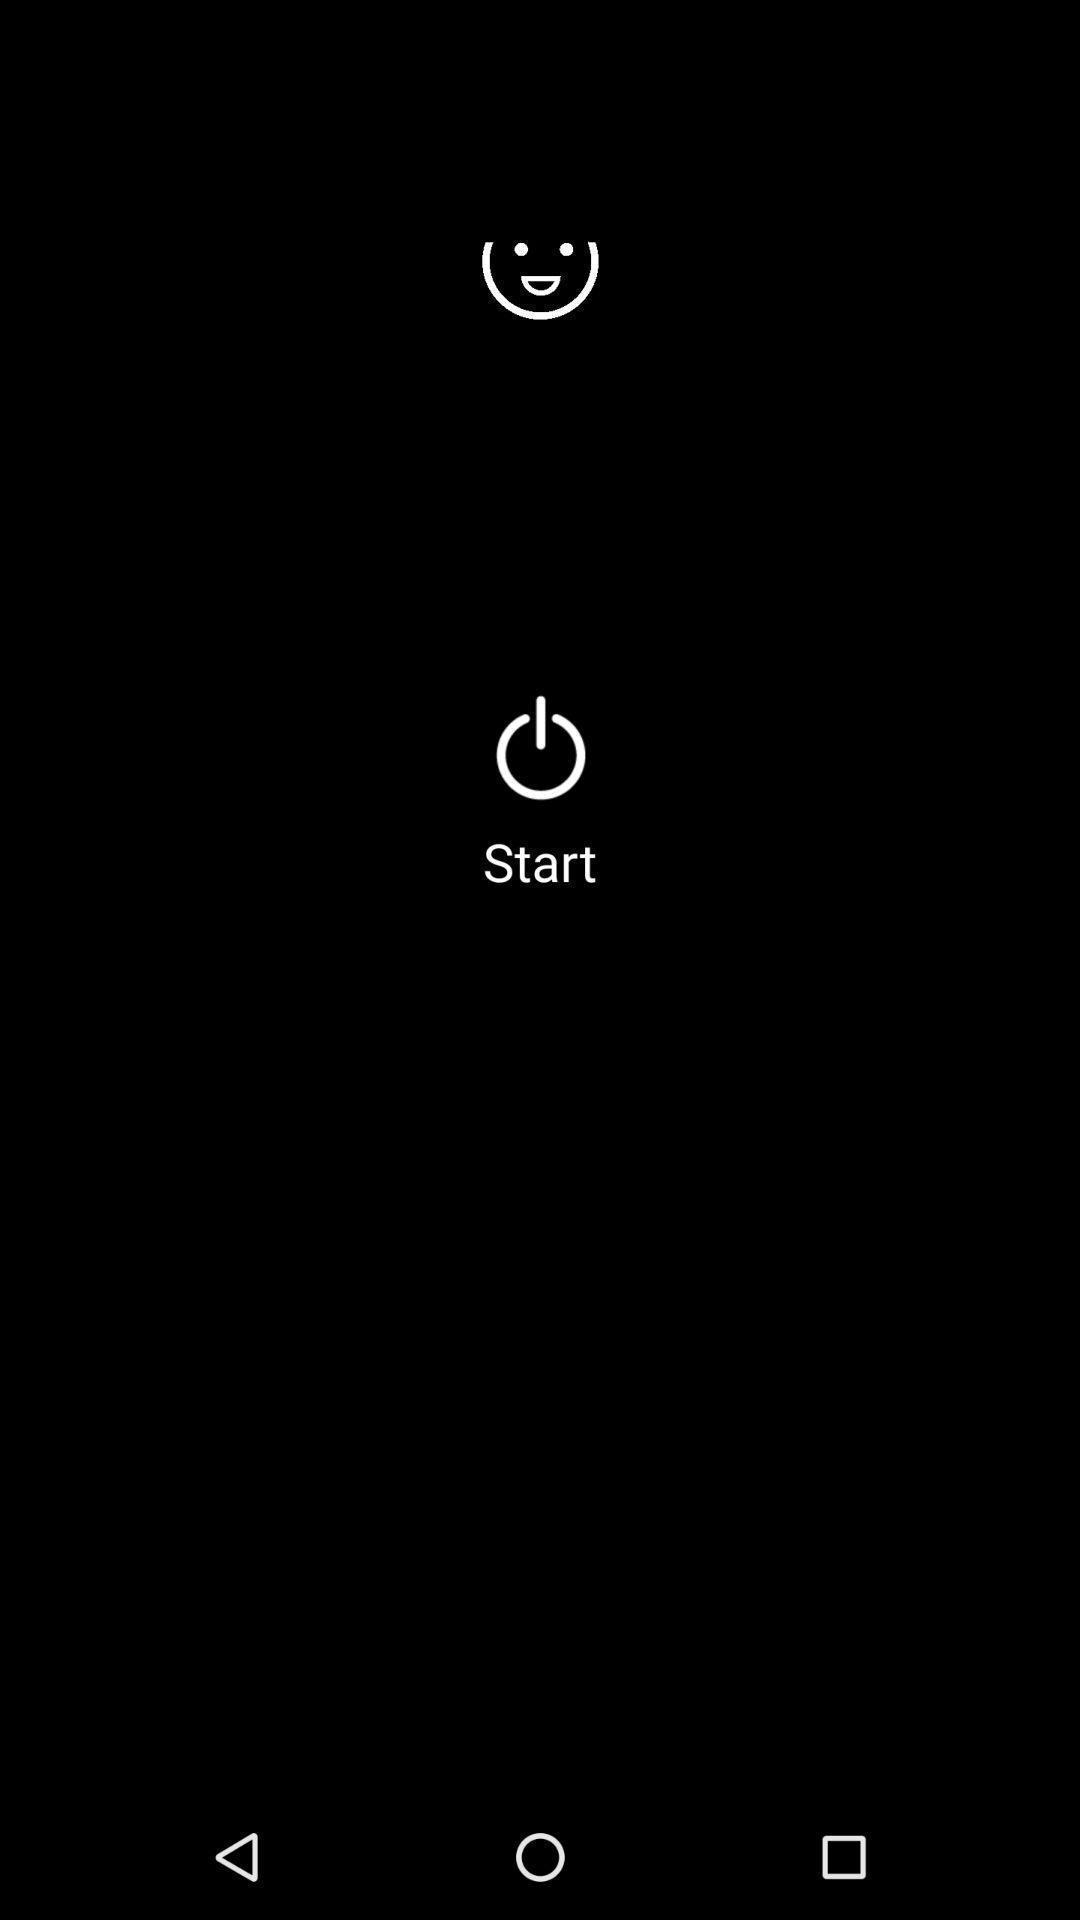What can you discern from this picture? Start page. 